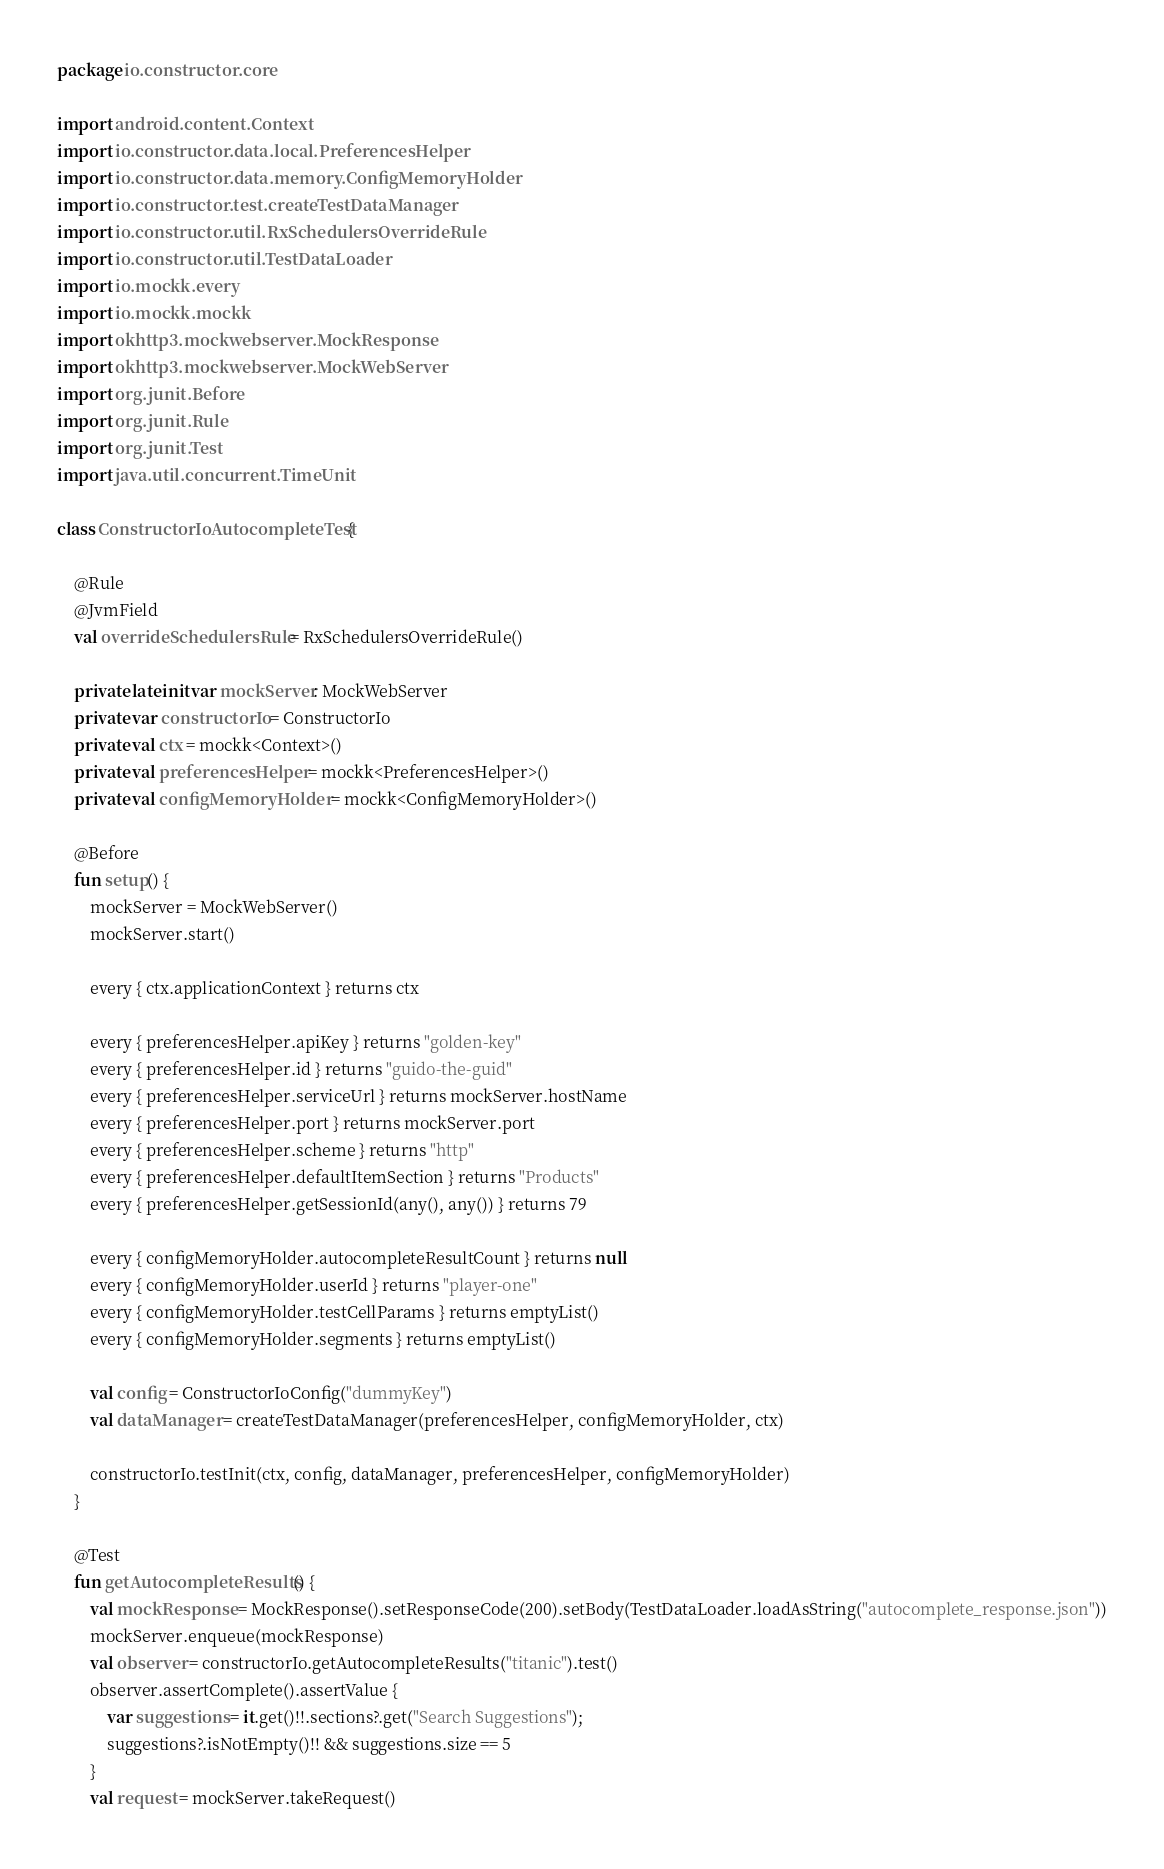<code> <loc_0><loc_0><loc_500><loc_500><_Kotlin_>package io.constructor.core

import android.content.Context
import io.constructor.data.local.PreferencesHelper
import io.constructor.data.memory.ConfigMemoryHolder
import io.constructor.test.createTestDataManager
import io.constructor.util.RxSchedulersOverrideRule
import io.constructor.util.TestDataLoader
import io.mockk.every
import io.mockk.mockk
import okhttp3.mockwebserver.MockResponse
import okhttp3.mockwebserver.MockWebServer
import org.junit.Before
import org.junit.Rule
import org.junit.Test
import java.util.concurrent.TimeUnit

class ConstructorIoAutocompleteTest {

    @Rule
    @JvmField
    val overrideSchedulersRule = RxSchedulersOverrideRule()

    private lateinit var mockServer: MockWebServer
    private var constructorIo = ConstructorIo
    private val ctx = mockk<Context>()
    private val preferencesHelper = mockk<PreferencesHelper>()
    private val configMemoryHolder = mockk<ConfigMemoryHolder>()

    @Before
    fun setup() {
        mockServer = MockWebServer()
        mockServer.start()

        every { ctx.applicationContext } returns ctx

        every { preferencesHelper.apiKey } returns "golden-key"
        every { preferencesHelper.id } returns "guido-the-guid"
        every { preferencesHelper.serviceUrl } returns mockServer.hostName
        every { preferencesHelper.port } returns mockServer.port
        every { preferencesHelper.scheme } returns "http"
        every { preferencesHelper.defaultItemSection } returns "Products"
        every { preferencesHelper.getSessionId(any(), any()) } returns 79

        every { configMemoryHolder.autocompleteResultCount } returns null
        every { configMemoryHolder.userId } returns "player-one"
        every { configMemoryHolder.testCellParams } returns emptyList()
        every { configMemoryHolder.segments } returns emptyList()

        val config = ConstructorIoConfig("dummyKey")
        val dataManager = createTestDataManager(preferencesHelper, configMemoryHolder, ctx)

        constructorIo.testInit(ctx, config, dataManager, preferencesHelper, configMemoryHolder)
    }

    @Test
    fun getAutocompleteResults() {
        val mockResponse = MockResponse().setResponseCode(200).setBody(TestDataLoader.loadAsString("autocomplete_response.json"))
        mockServer.enqueue(mockResponse)
        val observer = constructorIo.getAutocompleteResults("titanic").test()
        observer.assertComplete().assertValue {
            var suggestions = it.get()!!.sections?.get("Search Suggestions");
            suggestions?.isNotEmpty()!! && suggestions.size == 5
        }
        val request = mockServer.takeRequest()</code> 